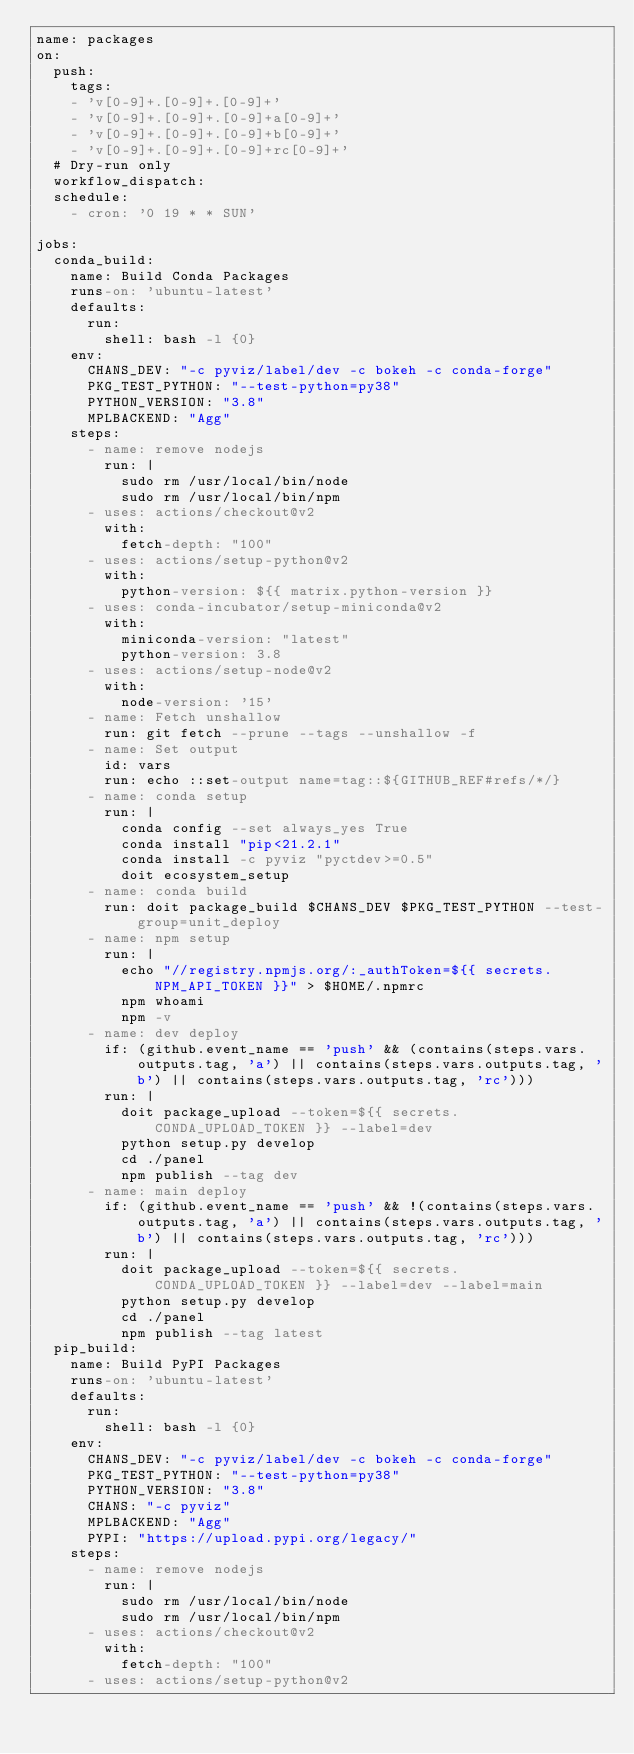Convert code to text. <code><loc_0><loc_0><loc_500><loc_500><_YAML_>name: packages
on:
  push:
    tags:
    - 'v[0-9]+.[0-9]+.[0-9]+'
    - 'v[0-9]+.[0-9]+.[0-9]+a[0-9]+'
    - 'v[0-9]+.[0-9]+.[0-9]+b[0-9]+'
    - 'v[0-9]+.[0-9]+.[0-9]+rc[0-9]+'
  # Dry-run only
  workflow_dispatch:
  schedule:
    - cron: '0 19 * * SUN'

jobs:
  conda_build:
    name: Build Conda Packages
    runs-on: 'ubuntu-latest'
    defaults:
      run:
        shell: bash -l {0}
    env:
      CHANS_DEV: "-c pyviz/label/dev -c bokeh -c conda-forge"
      PKG_TEST_PYTHON: "--test-python=py38"
      PYTHON_VERSION: "3.8"
      MPLBACKEND: "Agg"
    steps:
      - name: remove nodejs
        run: |
          sudo rm /usr/local/bin/node
          sudo rm /usr/local/bin/npm
      - uses: actions/checkout@v2
        with:
          fetch-depth: "100"
      - uses: actions/setup-python@v2
        with:
          python-version: ${{ matrix.python-version }}
      - uses: conda-incubator/setup-miniconda@v2
        with:
          miniconda-version: "latest"
          python-version: 3.8
      - uses: actions/setup-node@v2
        with:
          node-version: '15'
      - name: Fetch unshallow
        run: git fetch --prune --tags --unshallow -f
      - name: Set output
        id: vars
        run: echo ::set-output name=tag::${GITHUB_REF#refs/*/}
      - name: conda setup
        run: |
          conda config --set always_yes True
          conda install "pip<21.2.1" 
          conda install -c pyviz "pyctdev>=0.5"
          doit ecosystem_setup
      - name: conda build
        run: doit package_build $CHANS_DEV $PKG_TEST_PYTHON --test-group=unit_deploy
      - name: npm setup
        run: |
          echo "//registry.npmjs.org/:_authToken=${{ secrets.NPM_API_TOKEN }}" > $HOME/.npmrc
          npm whoami
          npm -v
      - name: dev deploy
        if: (github.event_name == 'push' && (contains(steps.vars.outputs.tag, 'a') || contains(steps.vars.outputs.tag, 'b') || contains(steps.vars.outputs.tag, 'rc')))
        run: |
          doit package_upload --token=${{ secrets.CONDA_UPLOAD_TOKEN }} --label=dev
          python setup.py develop
          cd ./panel
          npm publish --tag dev
      - name: main deploy
        if: (github.event_name == 'push' && !(contains(steps.vars.outputs.tag, 'a') || contains(steps.vars.outputs.tag, 'b') || contains(steps.vars.outputs.tag, 'rc')))
        run: |
          doit package_upload --token=${{ secrets.CONDA_UPLOAD_TOKEN }} --label=dev --label=main
          python setup.py develop
          cd ./panel
          npm publish --tag latest
  pip_build:
    name: Build PyPI Packages
    runs-on: 'ubuntu-latest'
    defaults:
      run:
        shell: bash -l {0}
    env:
      CHANS_DEV: "-c pyviz/label/dev -c bokeh -c conda-forge"
      PKG_TEST_PYTHON: "--test-python=py38"
      PYTHON_VERSION: "3.8"
      CHANS: "-c pyviz"
      MPLBACKEND: "Agg"
      PYPI: "https://upload.pypi.org/legacy/"
    steps:
      - name: remove nodejs
        run: |
          sudo rm /usr/local/bin/node
          sudo rm /usr/local/bin/npm
      - uses: actions/checkout@v2
        with:
          fetch-depth: "100"
      - uses: actions/setup-python@v2</code> 